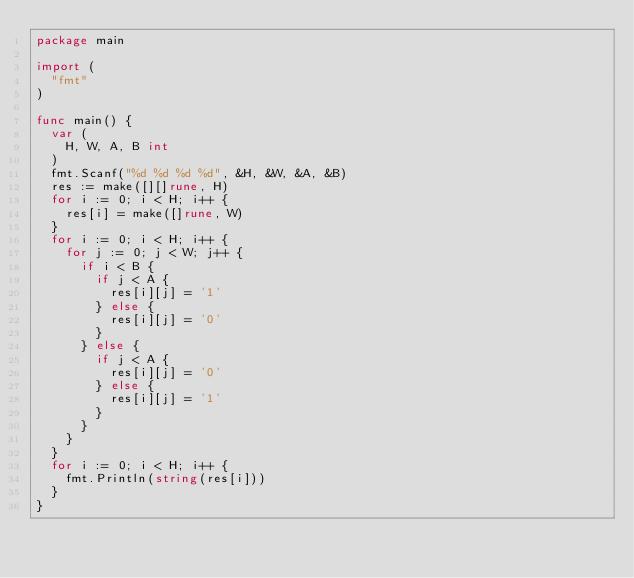<code> <loc_0><loc_0><loc_500><loc_500><_Go_>package main

import (
	"fmt"
)

func main() {
	var (
		H, W, A, B int
	)
	fmt.Scanf("%d %d %d %d", &H, &W, &A, &B)
	res := make([][]rune, H)
	for i := 0; i < H; i++ {
		res[i] = make([]rune, W)
	}
	for i := 0; i < H; i++ {
		for j := 0; j < W; j++ {
			if i < B {
				if j < A {
					res[i][j] = '1'
				} else {
					res[i][j] = '0'
				}
			} else {
				if j < A {
					res[i][j] = '0'
				} else {
					res[i][j] = '1'
				}
			}
		}
	}
	for i := 0; i < H; i++ {
		fmt.Println(string(res[i]))
	}
}
</code> 